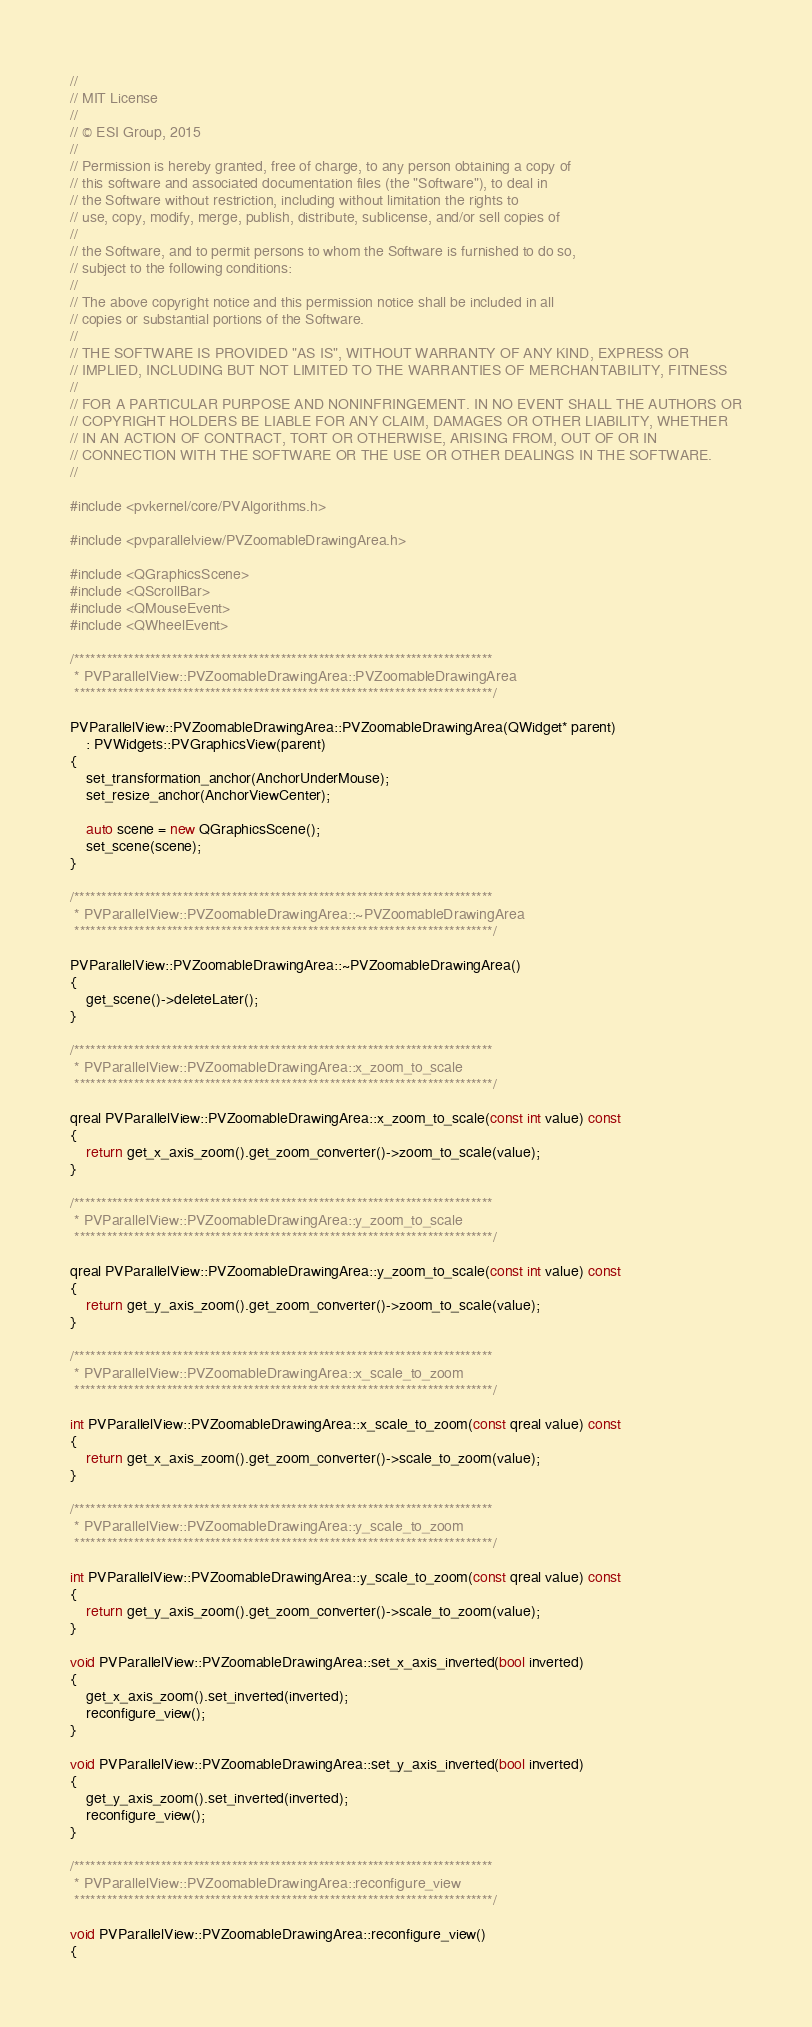<code> <loc_0><loc_0><loc_500><loc_500><_C++_>//
// MIT License
//
// © ESI Group, 2015
//
// Permission is hereby granted, free of charge, to any person obtaining a copy of
// this software and associated documentation files (the "Software"), to deal in
// the Software without restriction, including without limitation the rights to
// use, copy, modify, merge, publish, distribute, sublicense, and/or sell copies of
//
// the Software, and to permit persons to whom the Software is furnished to do so,
// subject to the following conditions:
//
// The above copyright notice and this permission notice shall be included in all
// copies or substantial portions of the Software.
//
// THE SOFTWARE IS PROVIDED "AS IS", WITHOUT WARRANTY OF ANY KIND, EXPRESS OR
// IMPLIED, INCLUDING BUT NOT LIMITED TO THE WARRANTIES OF MERCHANTABILITY, FITNESS
//
// FOR A PARTICULAR PURPOSE AND NONINFRINGEMENT. IN NO EVENT SHALL THE AUTHORS OR
// COPYRIGHT HOLDERS BE LIABLE FOR ANY CLAIM, DAMAGES OR OTHER LIABILITY, WHETHER
// IN AN ACTION OF CONTRACT, TORT OR OTHERWISE, ARISING FROM, OUT OF OR IN
// CONNECTION WITH THE SOFTWARE OR THE USE OR OTHER DEALINGS IN THE SOFTWARE.
//

#include <pvkernel/core/PVAlgorithms.h>

#include <pvparallelview/PVZoomableDrawingArea.h>

#include <QGraphicsScene>
#include <QScrollBar>
#include <QMouseEvent>
#include <QWheelEvent>

/*****************************************************************************
 * PVParallelView::PVZoomableDrawingArea::PVZoomableDrawingArea
 *****************************************************************************/

PVParallelView::PVZoomableDrawingArea::PVZoomableDrawingArea(QWidget* parent)
    : PVWidgets::PVGraphicsView(parent)
{
	set_transformation_anchor(AnchorUnderMouse);
	set_resize_anchor(AnchorViewCenter);

	auto scene = new QGraphicsScene();
	set_scene(scene);
}

/*****************************************************************************
 * PVParallelView::PVZoomableDrawingArea::~PVZoomableDrawingArea
 *****************************************************************************/

PVParallelView::PVZoomableDrawingArea::~PVZoomableDrawingArea()
{
	get_scene()->deleteLater();
}

/*****************************************************************************
 * PVParallelView::PVZoomableDrawingArea::x_zoom_to_scale
 *****************************************************************************/

qreal PVParallelView::PVZoomableDrawingArea::x_zoom_to_scale(const int value) const
{
	return get_x_axis_zoom().get_zoom_converter()->zoom_to_scale(value);
}

/*****************************************************************************
 * PVParallelView::PVZoomableDrawingArea::y_zoom_to_scale
 *****************************************************************************/

qreal PVParallelView::PVZoomableDrawingArea::y_zoom_to_scale(const int value) const
{
	return get_y_axis_zoom().get_zoom_converter()->zoom_to_scale(value);
}

/*****************************************************************************
 * PVParallelView::PVZoomableDrawingArea::x_scale_to_zoom
 *****************************************************************************/

int PVParallelView::PVZoomableDrawingArea::x_scale_to_zoom(const qreal value) const
{
	return get_x_axis_zoom().get_zoom_converter()->scale_to_zoom(value);
}

/*****************************************************************************
 * PVParallelView::PVZoomableDrawingArea::y_scale_to_zoom
 *****************************************************************************/

int PVParallelView::PVZoomableDrawingArea::y_scale_to_zoom(const qreal value) const
{
	return get_y_axis_zoom().get_zoom_converter()->scale_to_zoom(value);
}

void PVParallelView::PVZoomableDrawingArea::set_x_axis_inverted(bool inverted)
{
	get_x_axis_zoom().set_inverted(inverted);
	reconfigure_view();
}

void PVParallelView::PVZoomableDrawingArea::set_y_axis_inverted(bool inverted)
{
	get_y_axis_zoom().set_inverted(inverted);
	reconfigure_view();
}

/*****************************************************************************
 * PVParallelView::PVZoomableDrawingArea::reconfigure_view
 *****************************************************************************/

void PVParallelView::PVZoomableDrawingArea::reconfigure_view()
{</code> 